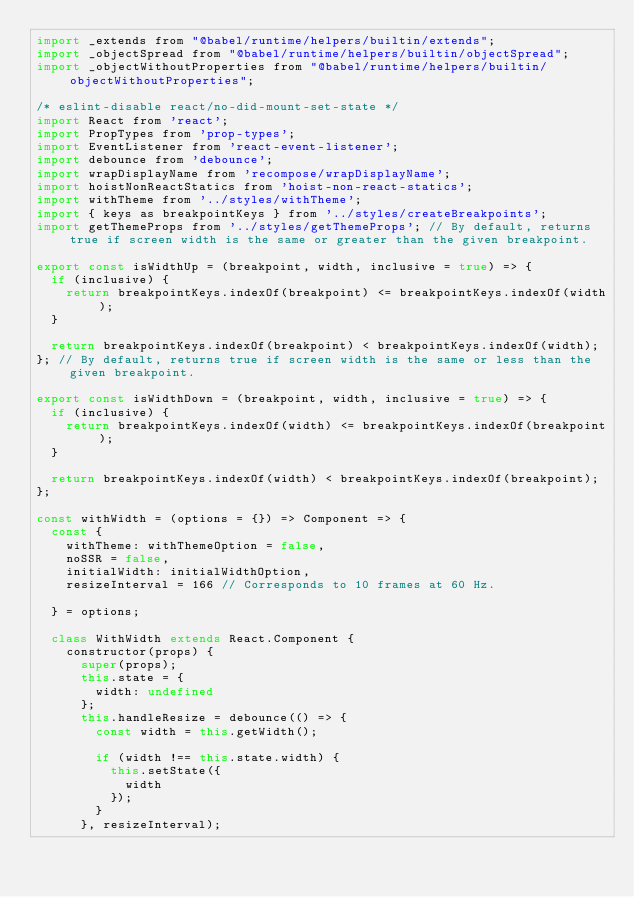<code> <loc_0><loc_0><loc_500><loc_500><_JavaScript_>import _extends from "@babel/runtime/helpers/builtin/extends";
import _objectSpread from "@babel/runtime/helpers/builtin/objectSpread";
import _objectWithoutProperties from "@babel/runtime/helpers/builtin/objectWithoutProperties";

/* eslint-disable react/no-did-mount-set-state */
import React from 'react';
import PropTypes from 'prop-types';
import EventListener from 'react-event-listener';
import debounce from 'debounce';
import wrapDisplayName from 'recompose/wrapDisplayName';
import hoistNonReactStatics from 'hoist-non-react-statics';
import withTheme from '../styles/withTheme';
import { keys as breakpointKeys } from '../styles/createBreakpoints';
import getThemeProps from '../styles/getThemeProps'; // By default, returns true if screen width is the same or greater than the given breakpoint.

export const isWidthUp = (breakpoint, width, inclusive = true) => {
  if (inclusive) {
    return breakpointKeys.indexOf(breakpoint) <= breakpointKeys.indexOf(width);
  }

  return breakpointKeys.indexOf(breakpoint) < breakpointKeys.indexOf(width);
}; // By default, returns true if screen width is the same or less than the given breakpoint.

export const isWidthDown = (breakpoint, width, inclusive = true) => {
  if (inclusive) {
    return breakpointKeys.indexOf(width) <= breakpointKeys.indexOf(breakpoint);
  }

  return breakpointKeys.indexOf(width) < breakpointKeys.indexOf(breakpoint);
};

const withWidth = (options = {}) => Component => {
  const {
    withTheme: withThemeOption = false,
    noSSR = false,
    initialWidth: initialWidthOption,
    resizeInterval = 166 // Corresponds to 10 frames at 60 Hz.

  } = options;

  class WithWidth extends React.Component {
    constructor(props) {
      super(props);
      this.state = {
        width: undefined
      };
      this.handleResize = debounce(() => {
        const width = this.getWidth();

        if (width !== this.state.width) {
          this.setState({
            width
          });
        }
      }, resizeInterval);
</code> 